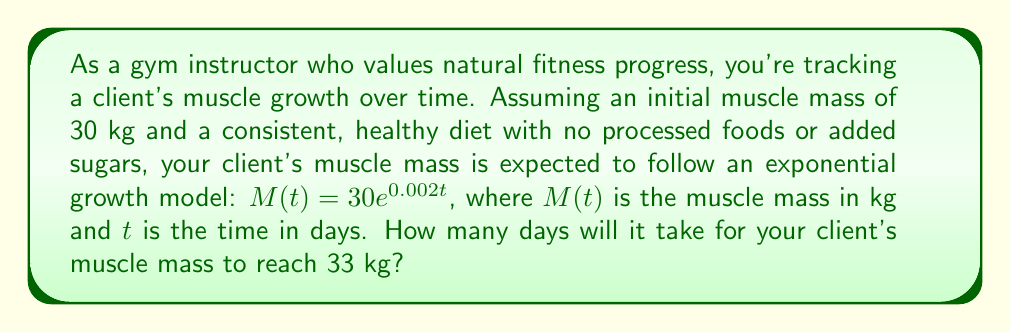Show me your answer to this math problem. To solve this problem, we need to use the given exponential growth model and solve for $t$ when $M(t) = 33$. Let's break it down step by step:

1) We start with the equation: $M(t) = 30e^{0.002t}$

2) We want to find $t$ when $M(t) = 33$, so we set up the equation:
   $33 = 30e^{0.002t}$

3) Divide both sides by 30:
   $\frac{33}{30} = e^{0.002t}$

4) Take the natural logarithm of both sides:
   $\ln(\frac{33}{30}) = \ln(e^{0.002t})$

5) Using the property of logarithms, $\ln(e^x) = x$, we get:
   $\ln(\frac{33}{30}) = 0.002t$

6) Solve for $t$ by dividing both sides by 0.002:
   $t = \frac{\ln(\frac{33}{30})}{0.002}$

7) Calculate the value:
   $t = \frac{\ln(1.1)}{0.002} \approx 47.6$ days

8) Since we're dealing with whole days, we round up to the nearest day.
Answer: It will take 48 days for the client's muscle mass to reach 33 kg. 